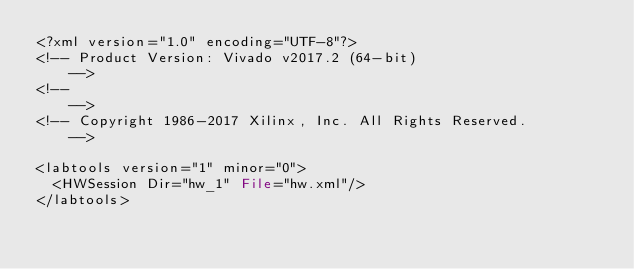<code> <loc_0><loc_0><loc_500><loc_500><_Pascal_><?xml version="1.0" encoding="UTF-8"?>
<!-- Product Version: Vivado v2017.2 (64-bit)                     -->
<!--                                                              -->
<!-- Copyright 1986-2017 Xilinx, Inc. All Rights Reserved.        -->

<labtools version="1" minor="0">
  <HWSession Dir="hw_1" File="hw.xml"/>
</labtools>
</code> 